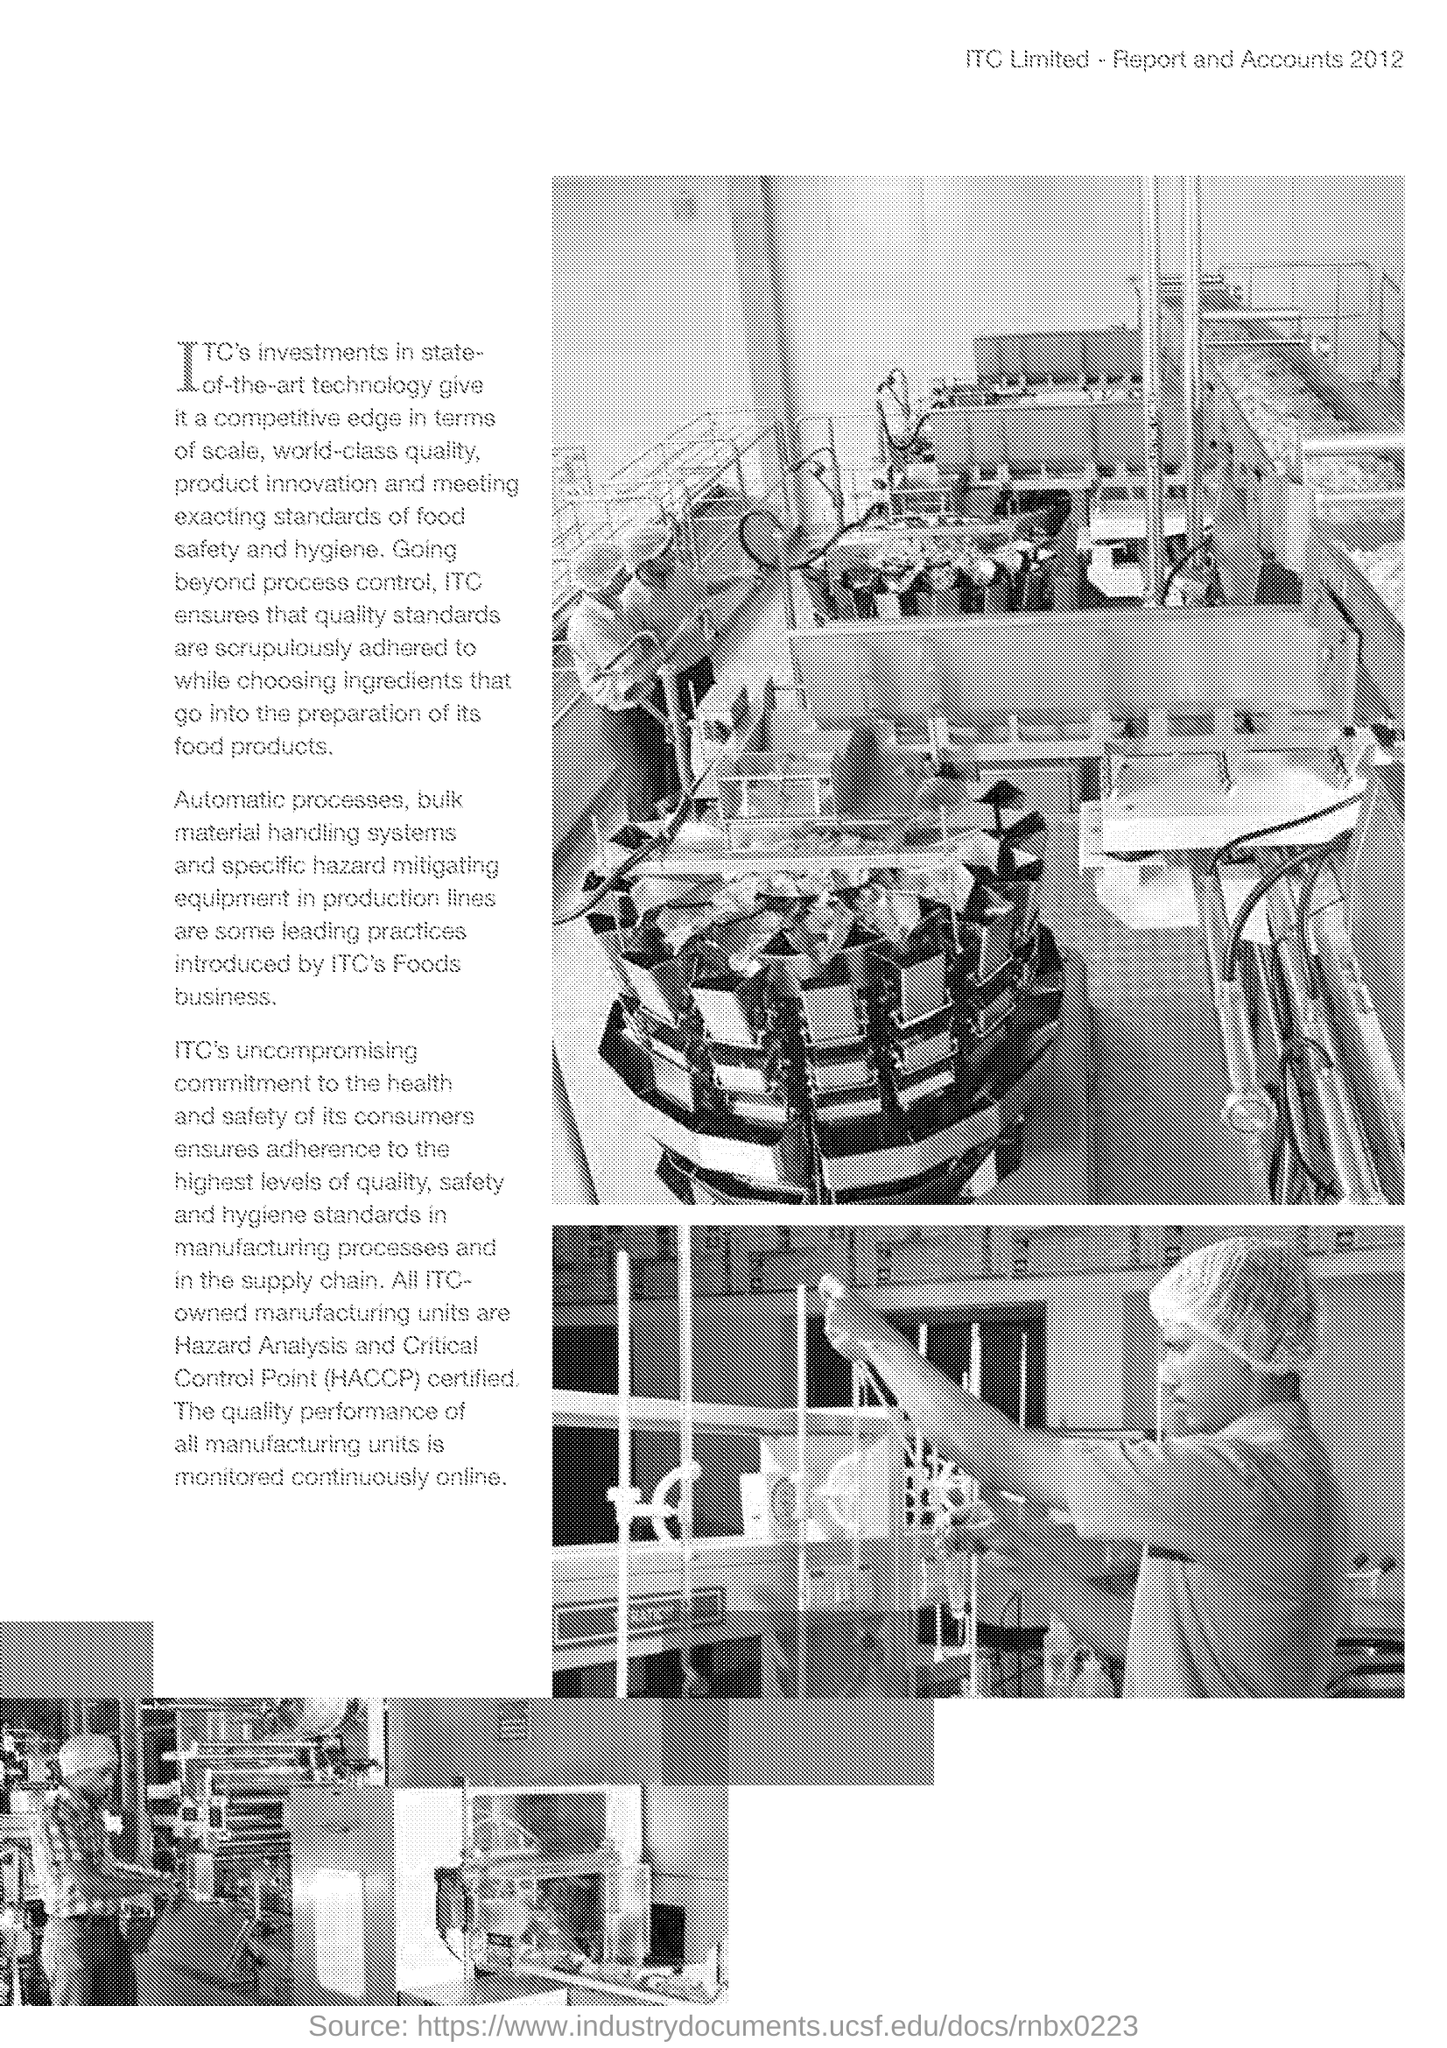Give some essential details in this illustration. The name of the journal is printed on the top of the page. It reads 'ITC Limited - Report and Accounts 2012.' 